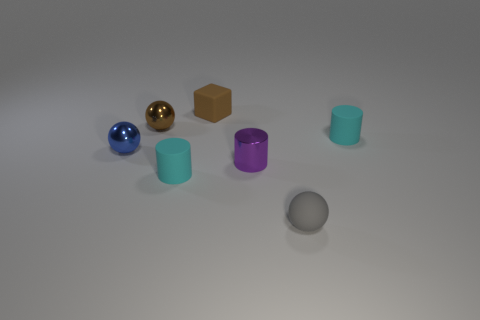Add 2 small gray rubber things. How many objects exist? 9 Subtract all cylinders. How many objects are left? 4 Add 7 brown metal things. How many brown metal things exist? 8 Subtract 0 green cylinders. How many objects are left? 7 Subtract all tiny blue metal spheres. Subtract all tiny gray balls. How many objects are left? 5 Add 6 brown metal balls. How many brown metal balls are left? 7 